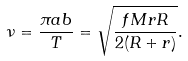<formula> <loc_0><loc_0><loc_500><loc_500>\nu = \frac { \pi a b } { T } = \sqrt { \frac { f M r R } { 2 ( R + r ) } } .</formula> 